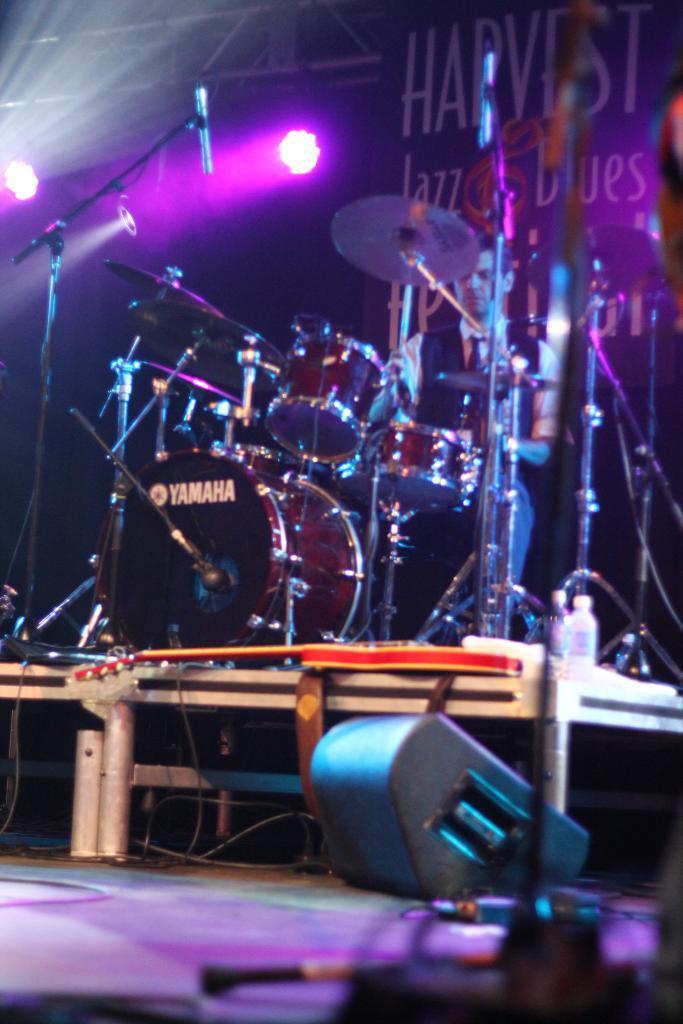In one or two sentences, can you explain what this image depicts? In this image there is a light at bottom of this image and there are some drugs are in middle of this image and there is one person is sitting at right side of this image and there are some lights at top of this image. 